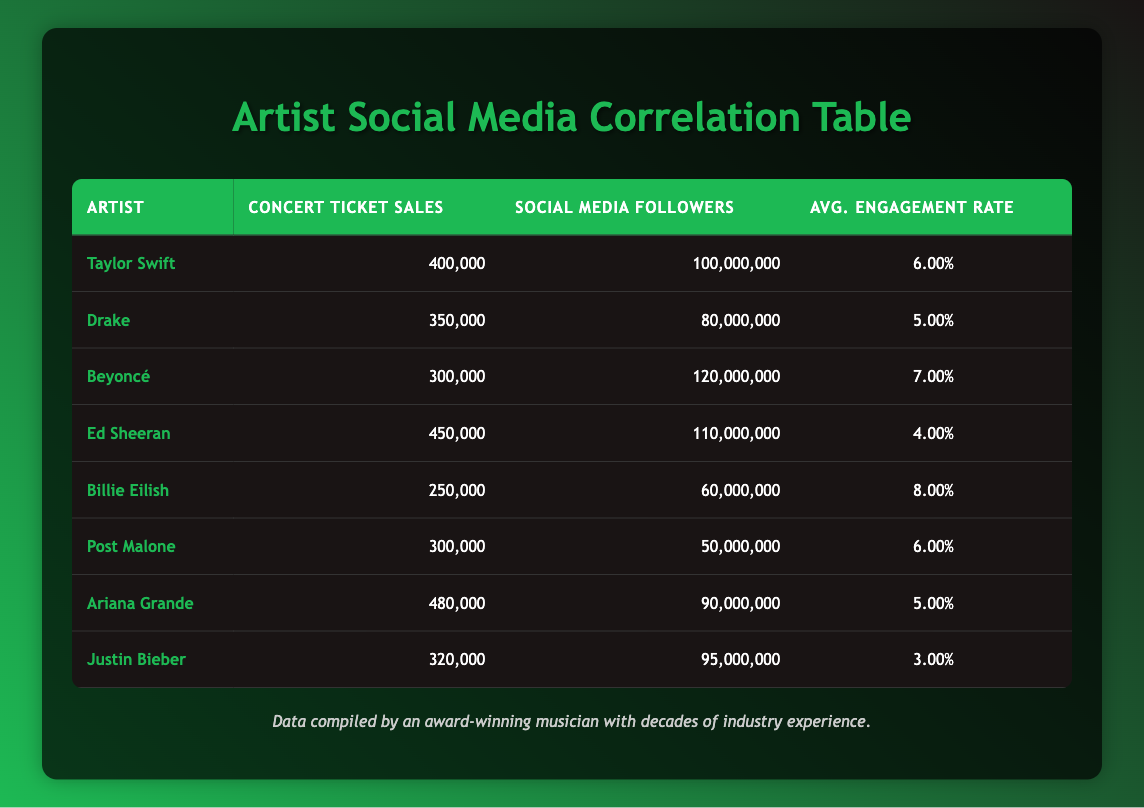What are the concert ticket sales for Taylor Swift? The table shows that Taylor Swift has concert ticket sales of 400,000.
Answer: 400,000 Which artist has the highest number of social media followers? By examining the "Social Media Followers" column, Beyoncé has the highest count with 120,000,000 followers.
Answer: Beyoncé What is the average concert ticket sales of the artists listed? To find the average, we sum the ticket sales: (400,000 + 350,000 + 300,000 + 450,000 + 250,000 + 300,000 + 480,000 + 320,000 = 2,830,000). Dividing this by the number of artists (8) gives 2,830,000 / 8 = 353,750.
Answer: 353,750 Is it true that Post Malone has a higher engagement rate than Justin Bieber? Post Malone's average engagement rate is 6.00%, while Justin Bieber's average engagement rate is 3.00%. Therefore, it is true that Post Malone has a higher engagement rate than Justin Bieber.
Answer: Yes Which artist has the lowest concert ticket sales and what is that number? The lowest concert ticket sales can be identified in the "Concert Ticket Sales" column, where Billie Eilish has 250,000 sales.
Answer: Billie Eilish, 250,000 What is the total number of social media followers for all artists combined? To get the total, we sum all the social media followers: 100,000,000 + 80,000,000 + 120,000,000 + 110,000,000 + 60,000,000 + 50,000,000 + 90,000,000 + 95,000,000 = 705,000,000.
Answer: 705,000,000 Which artist has concert ticket sales closest to the average? The average concert ticket sales are 353,750. The artist with sales closest to this average is Drake with 350,000, which is just 3,750 less than the average.
Answer: Drake Is the average engagement rate across the artists greater than 5%? First, we calculate the average engagement rate: (6.00% + 5.00% + 7.00% + 4.00% + 8.00% + 6.00% + 5.00% + 3.00%) / 8 = 5.125%. Since this value is greater than 5%, the answer is yes.
Answer: Yes What is the difference in concert ticket sales between Ed Sheeran and Ariana Grande? Ed Sheeran has 450,000 concert ticket sales, and Ariana Grande has 480,000. The difference is calculated as 480,000 - 450,000 = 30,000.
Answer: 30,000 